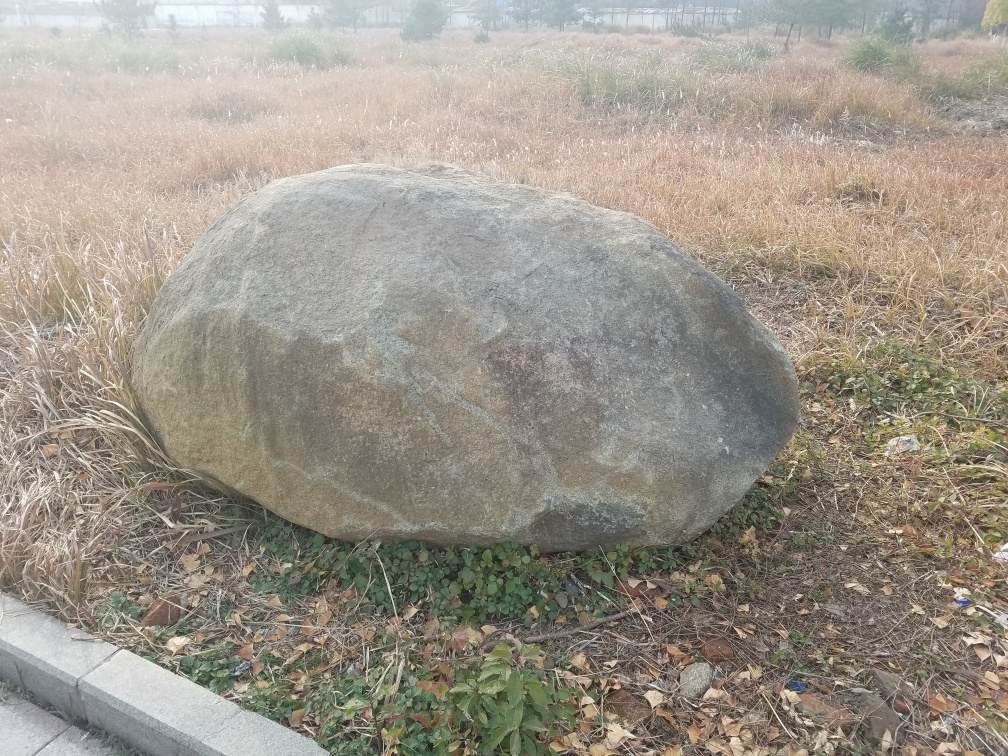What can you deduce about the ecosystem of the area from this image? The image shows a landscape transitioning from one season to another, possibly from fall to winter, considering the predominantly dried grass and a few resilient green plants. The presence of the boulder could indicate a relatively undisturbed area, as large stones like this are often moved or used by people in developed areas. The ecosystem here seems to support grassland vegetation and might attract various types of wildlife that utilize the rock for shelter or a vantage point. 